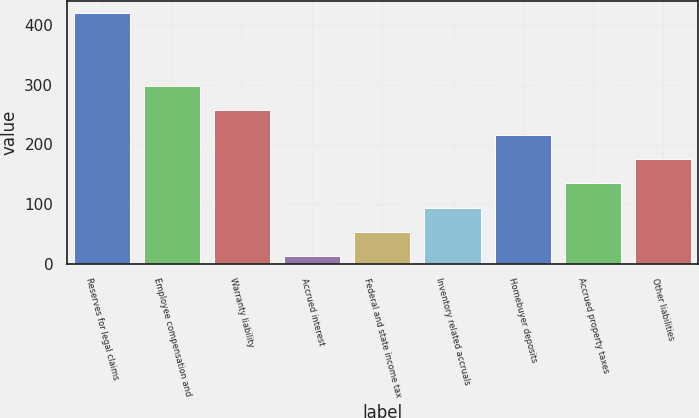Convert chart to OTSL. <chart><loc_0><loc_0><loc_500><loc_500><bar_chart><fcel>Reserves for legal claims<fcel>Employee compensation and<fcel>Warranty liability<fcel>Accrued interest<fcel>Federal and state income tax<fcel>Inventory related accruals<fcel>Homebuyer deposits<fcel>Accrued property taxes<fcel>Other liabilities<nl><fcel>420.6<fcel>297.99<fcel>257.12<fcel>11.9<fcel>52.77<fcel>93.64<fcel>216.25<fcel>134.51<fcel>175.38<nl></chart> 